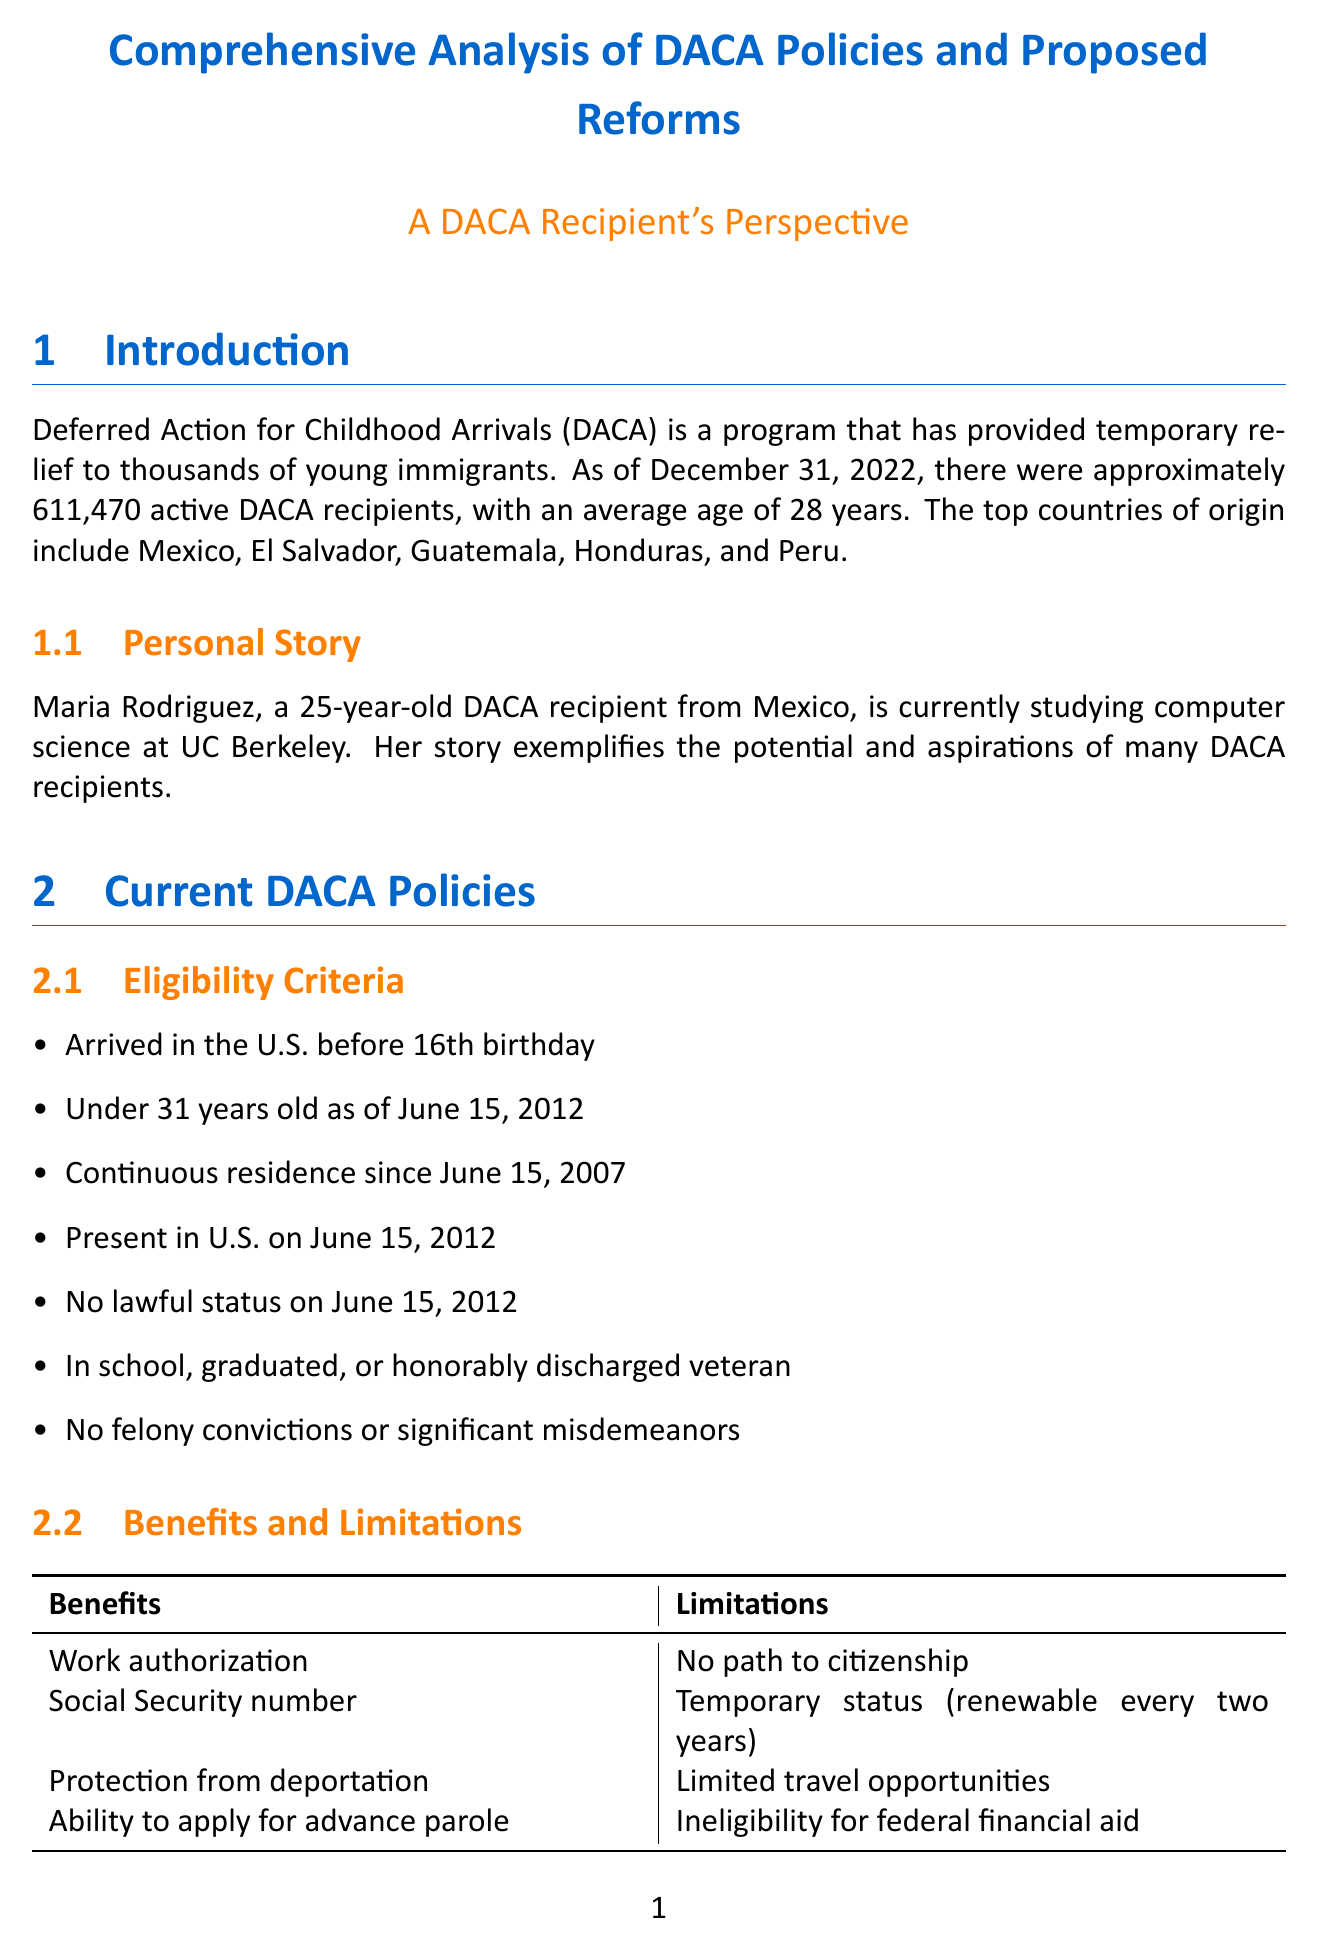What is the total number of active DACA recipients? The document states that there are about 611,470 active DACA recipients as of December 31, 2022.
Answer: About 611,470 What is the average age of DACA recipients? The average age of DACA recipients is mentioned in the introduction section.
Answer: 28 years old What key provision does the Dream Act propose? The Dream Act includes several key provisions, one of which is conditional permanent residency.
Answer: Conditional permanent residency for 8 years Who sponsored the American Dream and Promise Act? The document specifies that the American Dream and Promise Act was sponsored by a specific representative.
Answer: Representative Lucille Roybal-Allard What percentage of Americans support permanent legal status for DACA recipients? The public opinion section provides specific statistics regarding public support.
Answer: 74% What challenge does DACA currently face? The report identifies ongoing legal issues impacting DACA, presenting challenges in the immigration reform landscape.
Answer: Ongoing litigation in Texas v. United States case What impact could DACA recipients have on U.S. GDP? The report highlights the potential economic contributions of DACA recipients if certain conditions are met.
Answer: $433.4 billion over a decade What is a proposed reform to extend DACA's benefits? The document mentions several proposals to strengthen DACA, including changing the renewal period.
Answer: Extending DACA renewal period from two to five years 